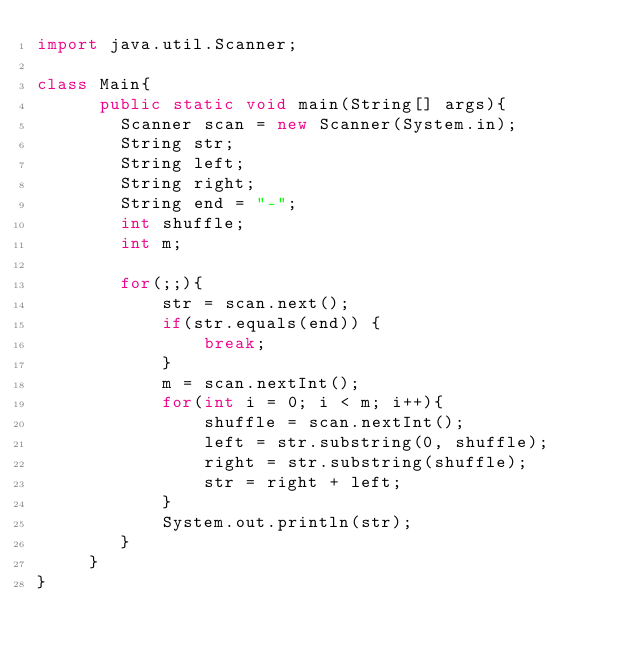Convert code to text. <code><loc_0><loc_0><loc_500><loc_500><_Java_>import java.util.Scanner;

class Main{
      public static void main(String[] args){
    	Scanner scan = new Scanner(System.in);
    	String str;
    	String left;
    	String right;
    	String end = "-";
    	int shuffle;
    	int m;
    	
    	for(;;){
    		str = scan.next();
    		if(str.equals(end)) {
    			break;
    		}
    		m = scan.nextInt();
    		for(int i = 0; i < m; i++){
    			shuffle = scan.nextInt();
    			left = str.substring(0, shuffle);
    			right = str.substring(shuffle);
    			str = right + left;
    		}
    		System.out.println(str);
    	}
     }
}</code> 